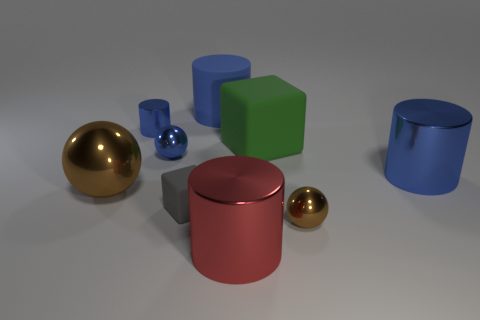Subtract all gray spheres. How many blue cylinders are left? 3 Add 1 brown things. How many objects exist? 10 Subtract all purple cylinders. Subtract all blue blocks. How many cylinders are left? 4 Subtract all rubber things. Subtract all red balls. How many objects are left? 6 Add 5 big brown metallic objects. How many big brown metallic objects are left? 6 Add 8 small blue metallic cylinders. How many small blue metallic cylinders exist? 9 Subtract 0 yellow cubes. How many objects are left? 9 Subtract all cylinders. How many objects are left? 5 